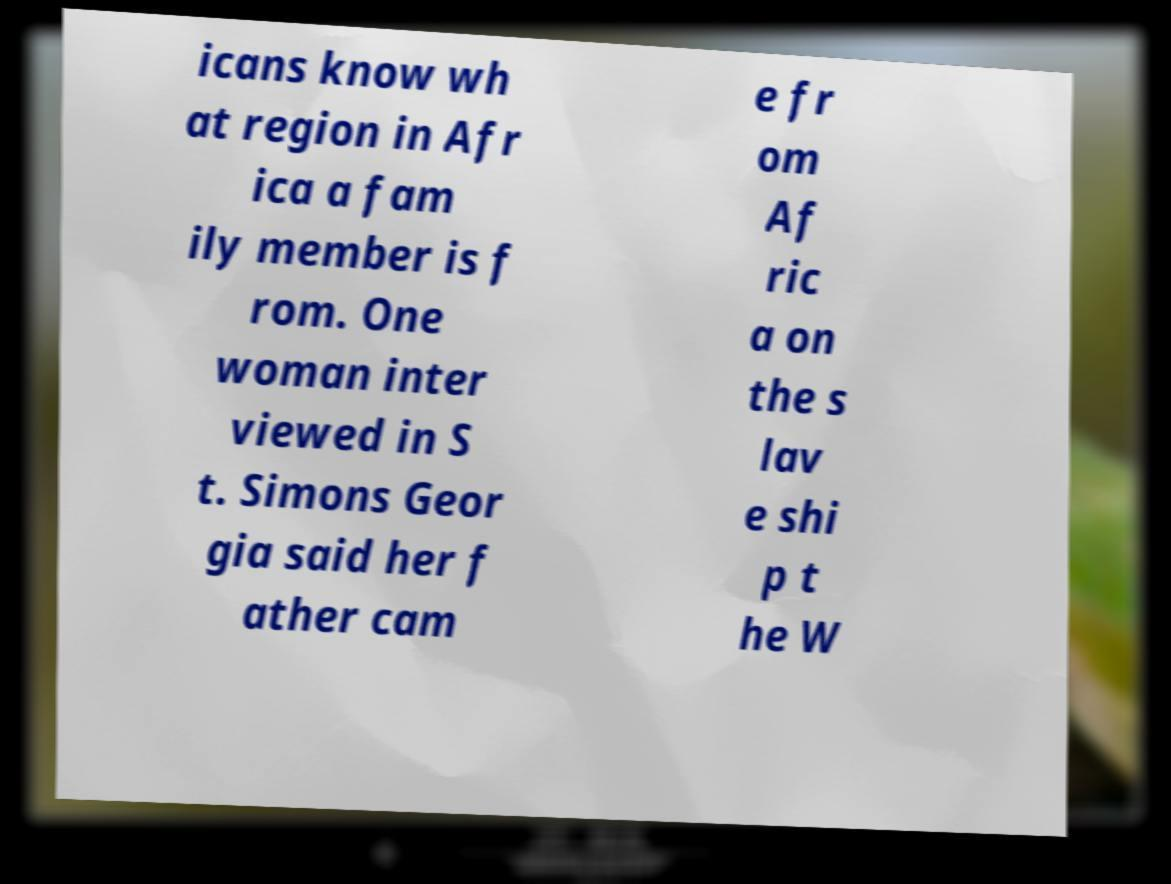For documentation purposes, I need the text within this image transcribed. Could you provide that? icans know wh at region in Afr ica a fam ily member is f rom. One woman inter viewed in S t. Simons Geor gia said her f ather cam e fr om Af ric a on the s lav e shi p t he W 